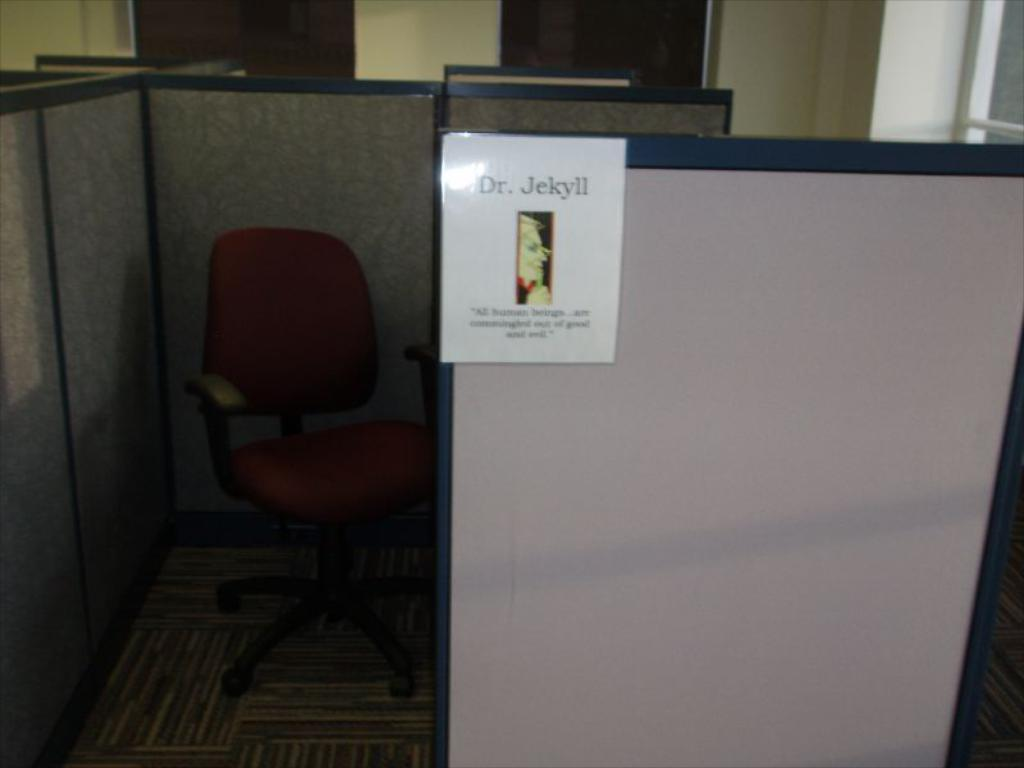Provide a one-sentence caption for the provided image. Office desk cubicle with a poster sign that says Dr. Jekyll. 